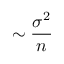<formula> <loc_0><loc_0><loc_500><loc_500>\sim \frac { \sigma ^ { 2 } } { n }</formula> 